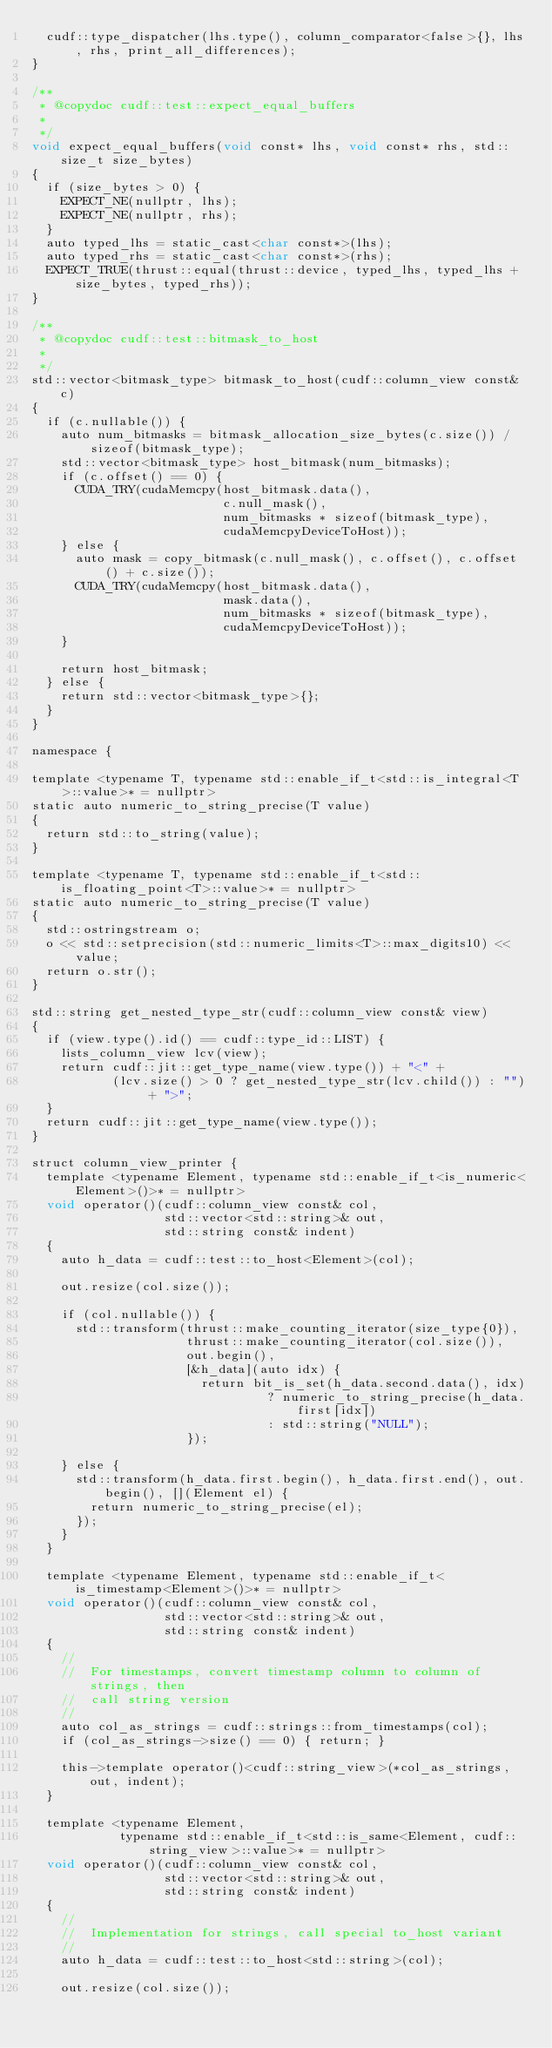Convert code to text. <code><loc_0><loc_0><loc_500><loc_500><_Cuda_>  cudf::type_dispatcher(lhs.type(), column_comparator<false>{}, lhs, rhs, print_all_differences);
}

/**
 * @copydoc cudf::test::expect_equal_buffers
 *
 */
void expect_equal_buffers(void const* lhs, void const* rhs, std::size_t size_bytes)
{
  if (size_bytes > 0) {
    EXPECT_NE(nullptr, lhs);
    EXPECT_NE(nullptr, rhs);
  }
  auto typed_lhs = static_cast<char const*>(lhs);
  auto typed_rhs = static_cast<char const*>(rhs);
  EXPECT_TRUE(thrust::equal(thrust::device, typed_lhs, typed_lhs + size_bytes, typed_rhs));
}

/**
 * @copydoc cudf::test::bitmask_to_host
 *
 */
std::vector<bitmask_type> bitmask_to_host(cudf::column_view const& c)
{
  if (c.nullable()) {
    auto num_bitmasks = bitmask_allocation_size_bytes(c.size()) / sizeof(bitmask_type);
    std::vector<bitmask_type> host_bitmask(num_bitmasks);
    if (c.offset() == 0) {
      CUDA_TRY(cudaMemcpy(host_bitmask.data(),
                          c.null_mask(),
                          num_bitmasks * sizeof(bitmask_type),
                          cudaMemcpyDeviceToHost));
    } else {
      auto mask = copy_bitmask(c.null_mask(), c.offset(), c.offset() + c.size());
      CUDA_TRY(cudaMemcpy(host_bitmask.data(),
                          mask.data(),
                          num_bitmasks * sizeof(bitmask_type),
                          cudaMemcpyDeviceToHost));
    }

    return host_bitmask;
  } else {
    return std::vector<bitmask_type>{};
  }
}

namespace {

template <typename T, typename std::enable_if_t<std::is_integral<T>::value>* = nullptr>
static auto numeric_to_string_precise(T value)
{
  return std::to_string(value);
}

template <typename T, typename std::enable_if_t<std::is_floating_point<T>::value>* = nullptr>
static auto numeric_to_string_precise(T value)
{
  std::ostringstream o;
  o << std::setprecision(std::numeric_limits<T>::max_digits10) << value;
  return o.str();
}

std::string get_nested_type_str(cudf::column_view const& view)
{
  if (view.type().id() == cudf::type_id::LIST) {
    lists_column_view lcv(view);
    return cudf::jit::get_type_name(view.type()) + "<" +
           (lcv.size() > 0 ? get_nested_type_str(lcv.child()) : "") + ">";
  }
  return cudf::jit::get_type_name(view.type());
}

struct column_view_printer {
  template <typename Element, typename std::enable_if_t<is_numeric<Element>()>* = nullptr>
  void operator()(cudf::column_view const& col,
                  std::vector<std::string>& out,
                  std::string const& indent)
  {
    auto h_data = cudf::test::to_host<Element>(col);

    out.resize(col.size());

    if (col.nullable()) {
      std::transform(thrust::make_counting_iterator(size_type{0}),
                     thrust::make_counting_iterator(col.size()),
                     out.begin(),
                     [&h_data](auto idx) {
                       return bit_is_set(h_data.second.data(), idx)
                                ? numeric_to_string_precise(h_data.first[idx])
                                : std::string("NULL");
                     });

    } else {
      std::transform(h_data.first.begin(), h_data.first.end(), out.begin(), [](Element el) {
        return numeric_to_string_precise(el);
      });
    }
  }

  template <typename Element, typename std::enable_if_t<is_timestamp<Element>()>* = nullptr>
  void operator()(cudf::column_view const& col,
                  std::vector<std::string>& out,
                  std::string const& indent)
  {
    //
    //  For timestamps, convert timestamp column to column of strings, then
    //  call string version
    //
    auto col_as_strings = cudf::strings::from_timestamps(col);
    if (col_as_strings->size() == 0) { return; }

    this->template operator()<cudf::string_view>(*col_as_strings, out, indent);
  }

  template <typename Element,
            typename std::enable_if_t<std::is_same<Element, cudf::string_view>::value>* = nullptr>
  void operator()(cudf::column_view const& col,
                  std::vector<std::string>& out,
                  std::string const& indent)
  {
    //
    //  Implementation for strings, call special to_host variant
    //
    auto h_data = cudf::test::to_host<std::string>(col);

    out.resize(col.size());</code> 